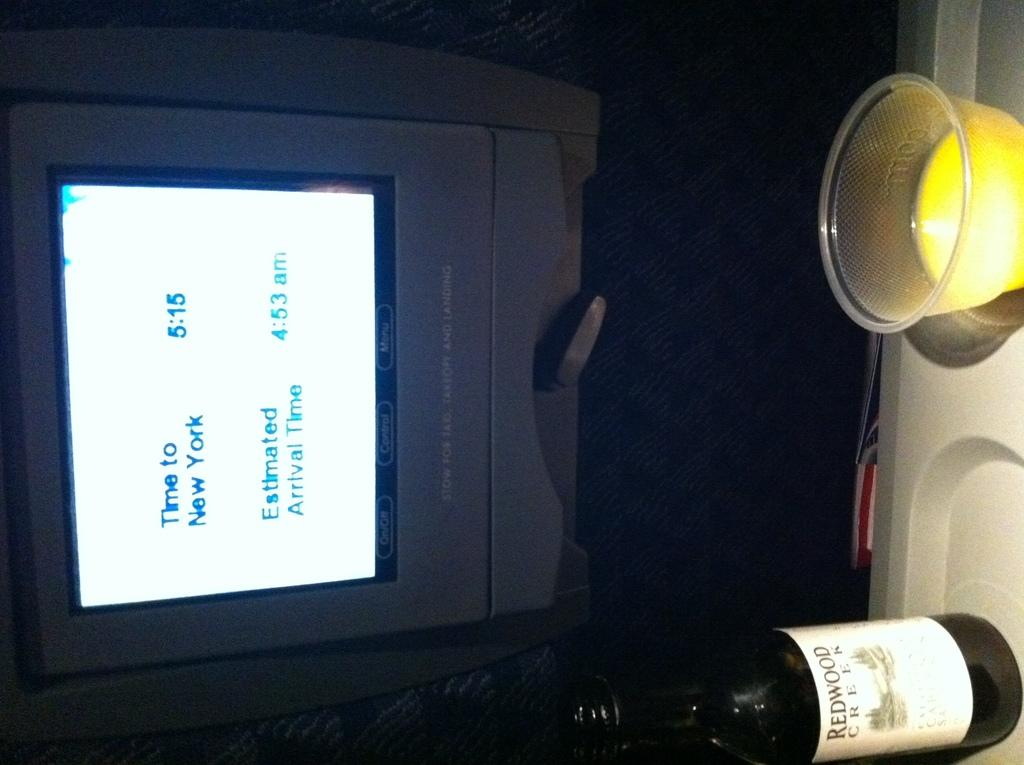<image>
Render a clear and concise summary of the photo. An information screen displays the time to New York as 5:15. 